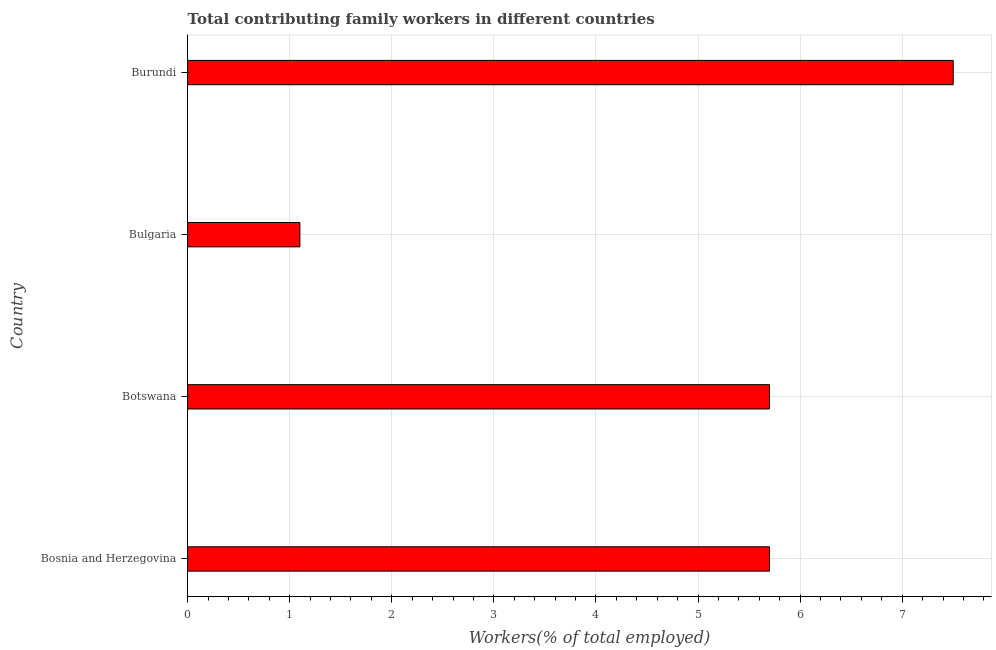What is the title of the graph?
Provide a short and direct response. Total contributing family workers in different countries. What is the label or title of the X-axis?
Ensure brevity in your answer.  Workers(% of total employed). What is the label or title of the Y-axis?
Offer a very short reply. Country. Across all countries, what is the maximum contributing family workers?
Ensure brevity in your answer.  7.5. Across all countries, what is the minimum contributing family workers?
Give a very brief answer. 1.1. In which country was the contributing family workers maximum?
Make the answer very short. Burundi. In which country was the contributing family workers minimum?
Give a very brief answer. Bulgaria. What is the sum of the contributing family workers?
Provide a succinct answer. 20. What is the difference between the contributing family workers in Bosnia and Herzegovina and Botswana?
Offer a very short reply. 0. What is the average contributing family workers per country?
Your answer should be compact. 5. What is the median contributing family workers?
Provide a succinct answer. 5.7. What is the ratio of the contributing family workers in Botswana to that in Burundi?
Ensure brevity in your answer.  0.76. Is the contributing family workers in Bosnia and Herzegovina less than that in Botswana?
Keep it short and to the point. No. Is the difference between the contributing family workers in Botswana and Burundi greater than the difference between any two countries?
Keep it short and to the point. No. What is the difference between the highest and the second highest contributing family workers?
Keep it short and to the point. 1.8. Is the sum of the contributing family workers in Botswana and Burundi greater than the maximum contributing family workers across all countries?
Keep it short and to the point. Yes. Are all the bars in the graph horizontal?
Make the answer very short. Yes. How many countries are there in the graph?
Offer a terse response. 4. What is the difference between two consecutive major ticks on the X-axis?
Your response must be concise. 1. Are the values on the major ticks of X-axis written in scientific E-notation?
Offer a terse response. No. What is the Workers(% of total employed) in Bosnia and Herzegovina?
Keep it short and to the point. 5.7. What is the Workers(% of total employed) of Botswana?
Ensure brevity in your answer.  5.7. What is the Workers(% of total employed) of Bulgaria?
Your response must be concise. 1.1. What is the Workers(% of total employed) of Burundi?
Your response must be concise. 7.5. What is the difference between the Workers(% of total employed) in Bosnia and Herzegovina and Botswana?
Ensure brevity in your answer.  0. What is the difference between the Workers(% of total employed) in Bosnia and Herzegovina and Bulgaria?
Keep it short and to the point. 4.6. What is the difference between the Workers(% of total employed) in Bosnia and Herzegovina and Burundi?
Provide a succinct answer. -1.8. What is the difference between the Workers(% of total employed) in Bulgaria and Burundi?
Make the answer very short. -6.4. What is the ratio of the Workers(% of total employed) in Bosnia and Herzegovina to that in Botswana?
Your answer should be very brief. 1. What is the ratio of the Workers(% of total employed) in Bosnia and Herzegovina to that in Bulgaria?
Keep it short and to the point. 5.18. What is the ratio of the Workers(% of total employed) in Bosnia and Herzegovina to that in Burundi?
Provide a short and direct response. 0.76. What is the ratio of the Workers(% of total employed) in Botswana to that in Bulgaria?
Provide a succinct answer. 5.18. What is the ratio of the Workers(% of total employed) in Botswana to that in Burundi?
Make the answer very short. 0.76. What is the ratio of the Workers(% of total employed) in Bulgaria to that in Burundi?
Ensure brevity in your answer.  0.15. 